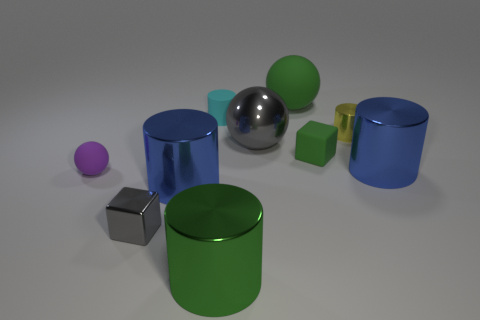Can you describe the textures visible in the scene? Certainly. The assorted objects in the scene exhibit a variety of textures. The spheres and cylinders have smooth and reflective surfaces, while the cube surfaces are matte with less reflection. The glossy finish on some provides a slight mirror effect, reflecting the environment and the other objects. 